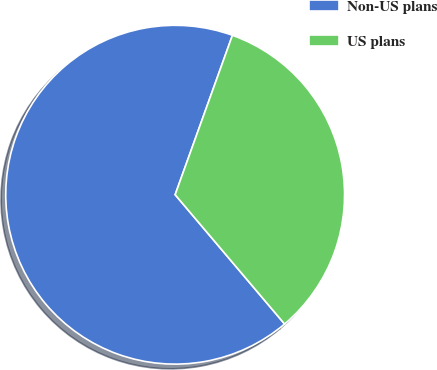<chart> <loc_0><loc_0><loc_500><loc_500><pie_chart><fcel>Non-US plans<fcel>US plans<nl><fcel>66.67%<fcel>33.33%<nl></chart> 